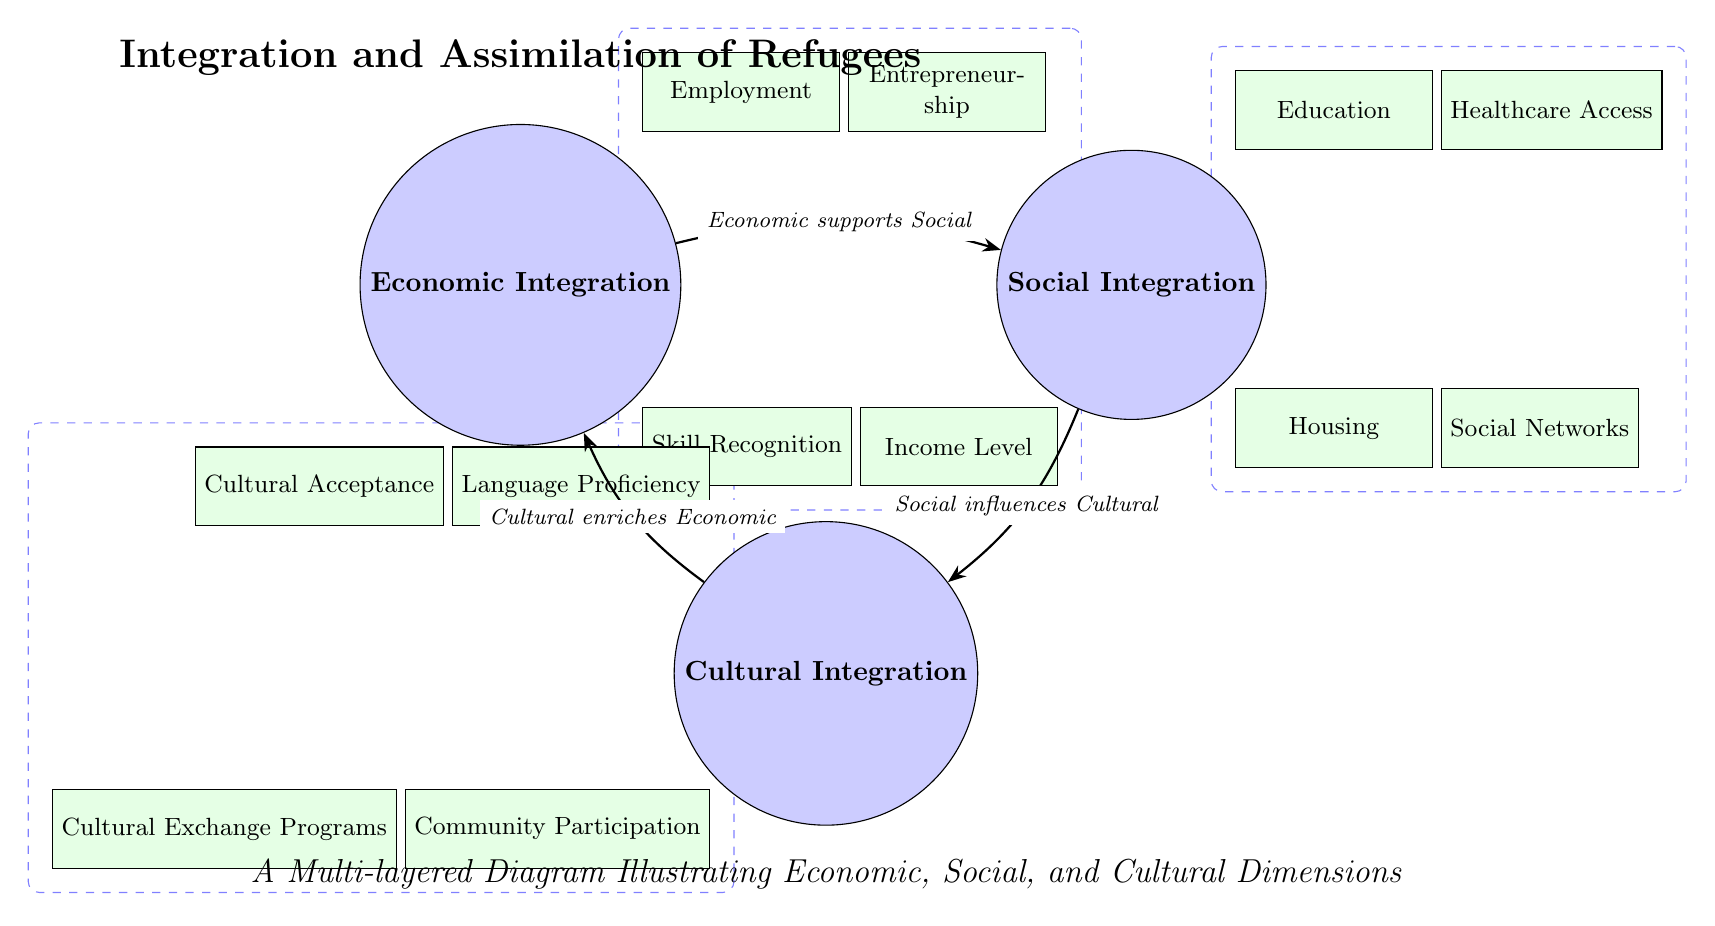What are the three main dimensions of integration illustrated in the diagram? The diagram identifies three main dimensions: Economic Integration, Social Integration, and Cultural Integration. These are the primary nodes in the diagram's structure.
Answer: Economic Integration, Social Integration, Cultural Integration Which sub-node is related to employment in the Economic dimension? In the Economic dimension, the sub-node related to employment is "Employment." It is positioned above right of the Economic Integration node.
Answer: Employment How many sub-nodes are connected to the Cultural Integration node? The Cultural Integration node is connected to four sub-nodes: Language Proficiency, Cultural Acceptance, Community Participation, and Cultural Exchange Programs. Counting these gives a total of four sub-nodes.
Answer: 4 What is the relationship between Social Integration and Cultural Integration? The diagram indicates that Social Integration influences Cultural Integration, which is shown by an arrow pointing from Social to Cultural, with the edge label stating the relationship.
Answer: Social influences Cultural What does the arrow from Economic Integration to Social Integration represent? The arrow from Economic Integration to Social Integration signifies that Economic supports Social, indicating a flow of support or influence from the Economic dimension to the Social dimension.
Answer: Economic supports Social Which sub-node is directly below the Social Integration node? Below the Social Integration node is the sub-node "Housing." This position can be confirmed by its placement in the diagram relative to the main node.
Answer: Housing How many edges are depicted in the diagram? The diagram depicts three edges that connect the main nodes of Economic, Social, and Cultural Integration, illustrating the relationships between them.
Answer: 3 What is the significance of the dashed boxes in the diagram? The dashed boxes in the diagram highlight groups of related sub-nodes within each main dimension (Economic, Social, Cultural), signifying their categorization and relationship to the corresponding main node.
Answer: Grouping sub-nodes Which sub-node under Social Integration addresses network support? The sub-node under Social Integration that addresses network support is "Social Networks." It is placed below right in the Social dimension section of the diagram.
Answer: Social Networks 